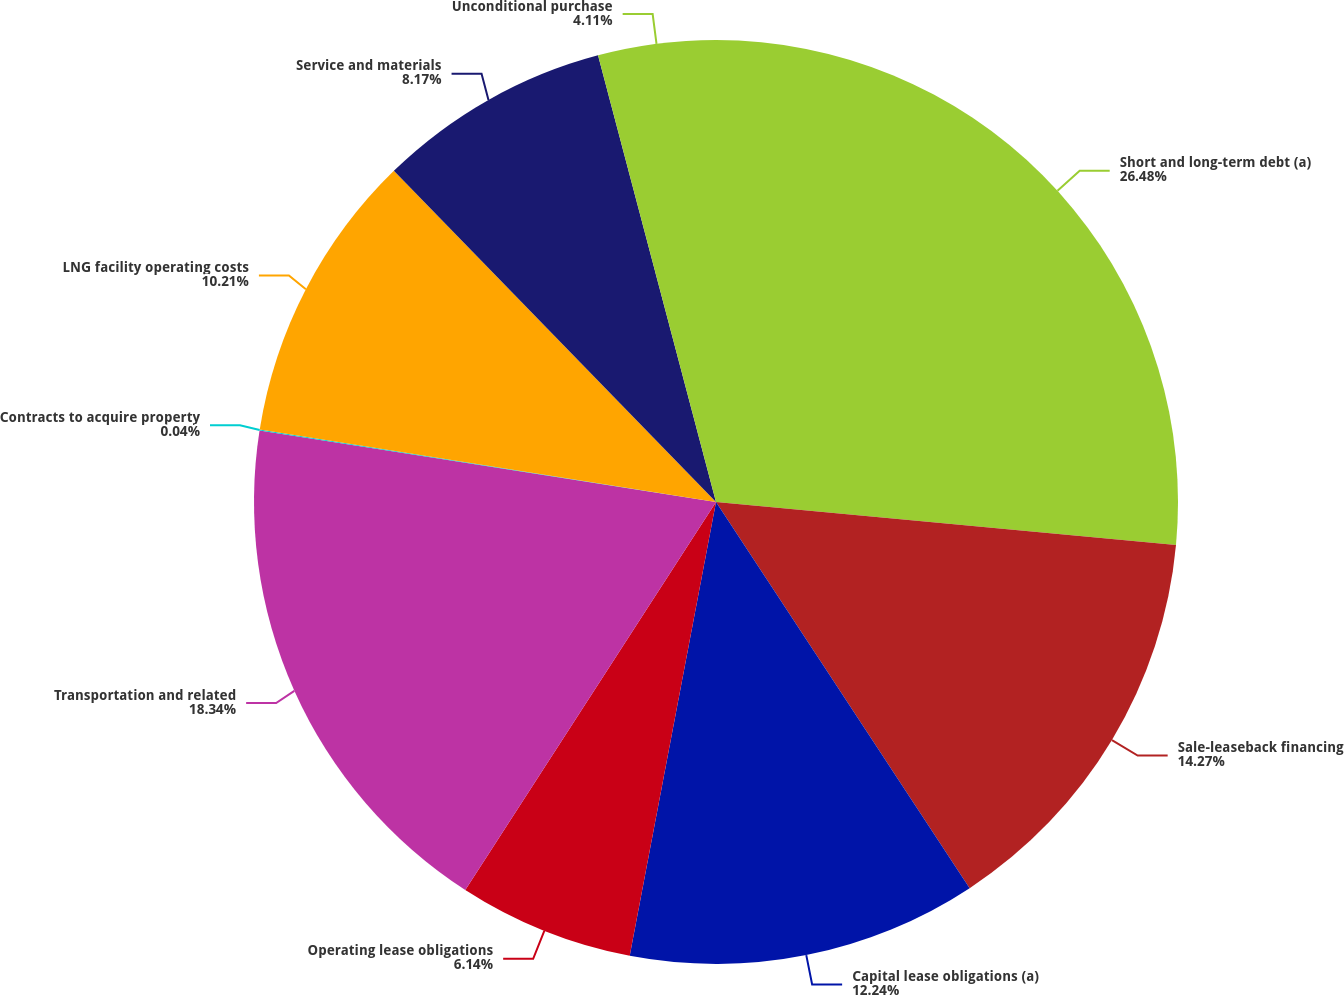Convert chart. <chart><loc_0><loc_0><loc_500><loc_500><pie_chart><fcel>Short and long-term debt (a)<fcel>Sale-leaseback financing<fcel>Capital lease obligations (a)<fcel>Operating lease obligations<fcel>Transportation and related<fcel>Contracts to acquire property<fcel>LNG facility operating costs<fcel>Service and materials<fcel>Unconditional purchase<nl><fcel>26.48%<fcel>14.27%<fcel>12.24%<fcel>6.14%<fcel>18.34%<fcel>0.04%<fcel>10.21%<fcel>8.17%<fcel>4.11%<nl></chart> 